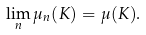<formula> <loc_0><loc_0><loc_500><loc_500>\lim _ { n } \mu _ { n } ( K ) = \mu ( K ) .</formula> 